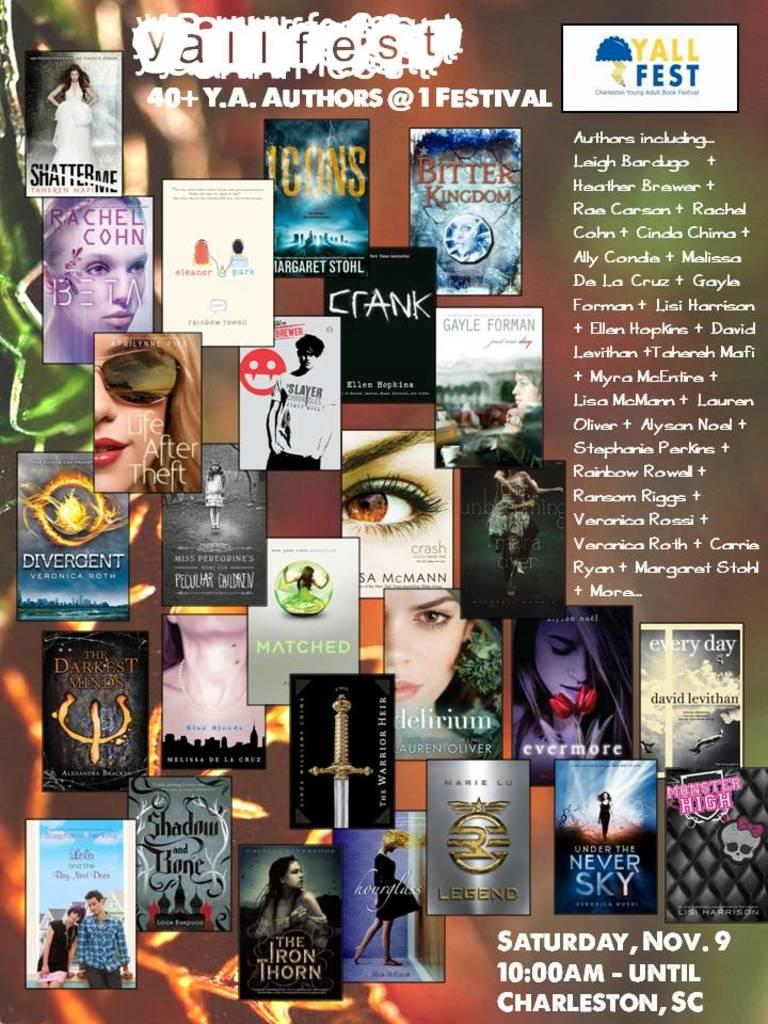<image>
Summarize the visual content of the image. A poster advertising the Yall Fest being held at 10:00AM on Saturday, November 9th in Charleston, SC. 